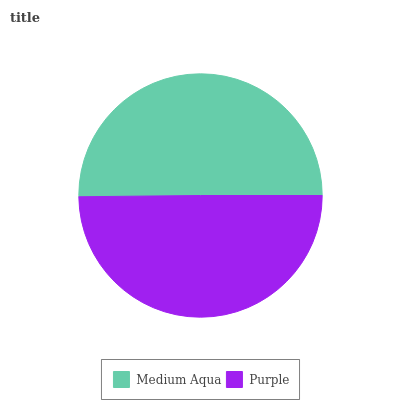Is Purple the minimum?
Answer yes or no. Yes. Is Medium Aqua the maximum?
Answer yes or no. Yes. Is Purple the maximum?
Answer yes or no. No. Is Medium Aqua greater than Purple?
Answer yes or no. Yes. Is Purple less than Medium Aqua?
Answer yes or no. Yes. Is Purple greater than Medium Aqua?
Answer yes or no. No. Is Medium Aqua less than Purple?
Answer yes or no. No. Is Medium Aqua the high median?
Answer yes or no. Yes. Is Purple the low median?
Answer yes or no. Yes. Is Purple the high median?
Answer yes or no. No. Is Medium Aqua the low median?
Answer yes or no. No. 